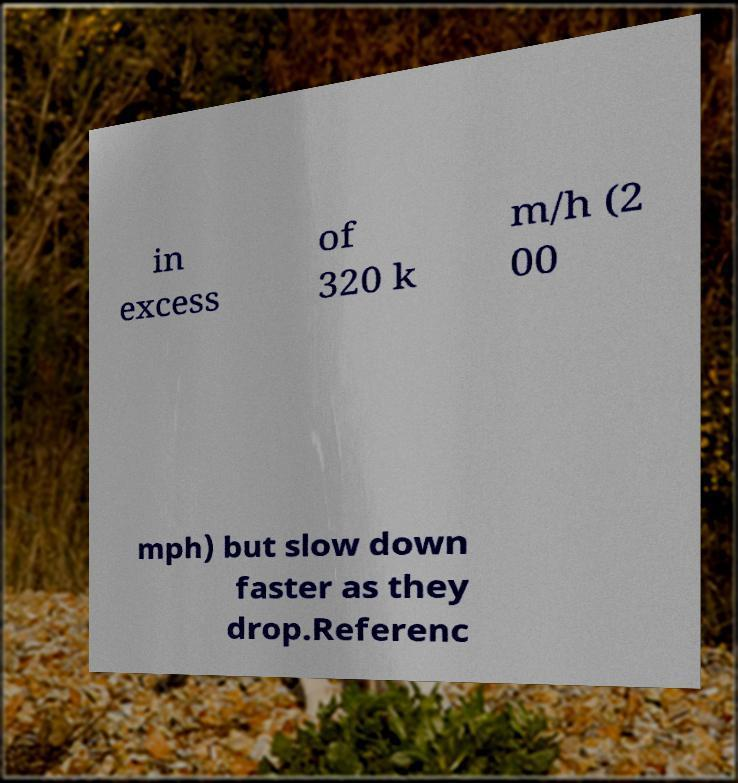Could you extract and type out the text from this image? in excess of 320 k m/h (2 00 mph) but slow down faster as they drop.Referenc 